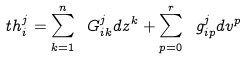Convert formula to latex. <formula><loc_0><loc_0><loc_500><loc_500>\ t h _ { i } ^ { j } = \sum _ { k = 1 } ^ { n } \ G ^ { j } _ { i k } d z ^ { k } + \sum _ { p = 0 } ^ { r } \ g ^ { j } _ { i p } d v ^ { p }</formula> 